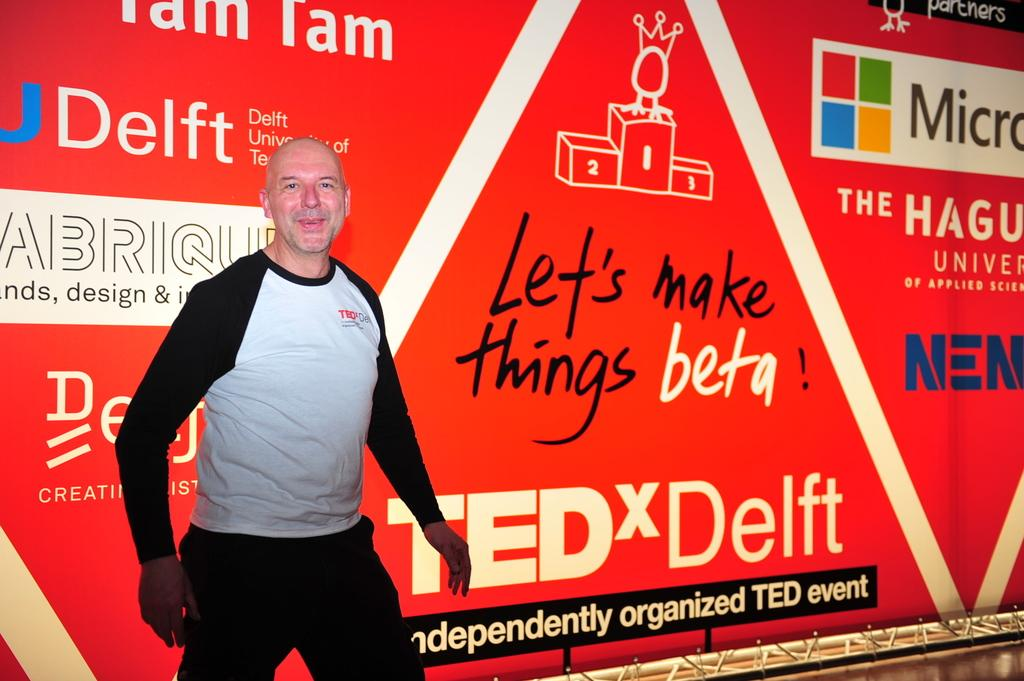Who is the main subject in the image? There is a man in the image. What is the man wearing? The man is wearing a black and white t-shirt. Where is the man positioned in the image? The man is standing in the front. What is the man's facial expression in the image? The man is smiling. What is the man doing in the image? The man is giving a pose to the camera. What can be seen in the background of the image? There is a red color advertising banner in the background. Can you see the man climbing a mountain in the image? No, there is no mountain present in the image. How does the man's breath look like in the image? There is no indication of the man's breath in the image. 